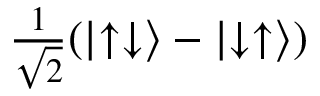<formula> <loc_0><loc_0><loc_500><loc_500>\frac { 1 } { \sqrt { 2 } } ( \left | \uparrow \downarrow \right \rangle - \left | \downarrow \uparrow \right \rangle )</formula> 